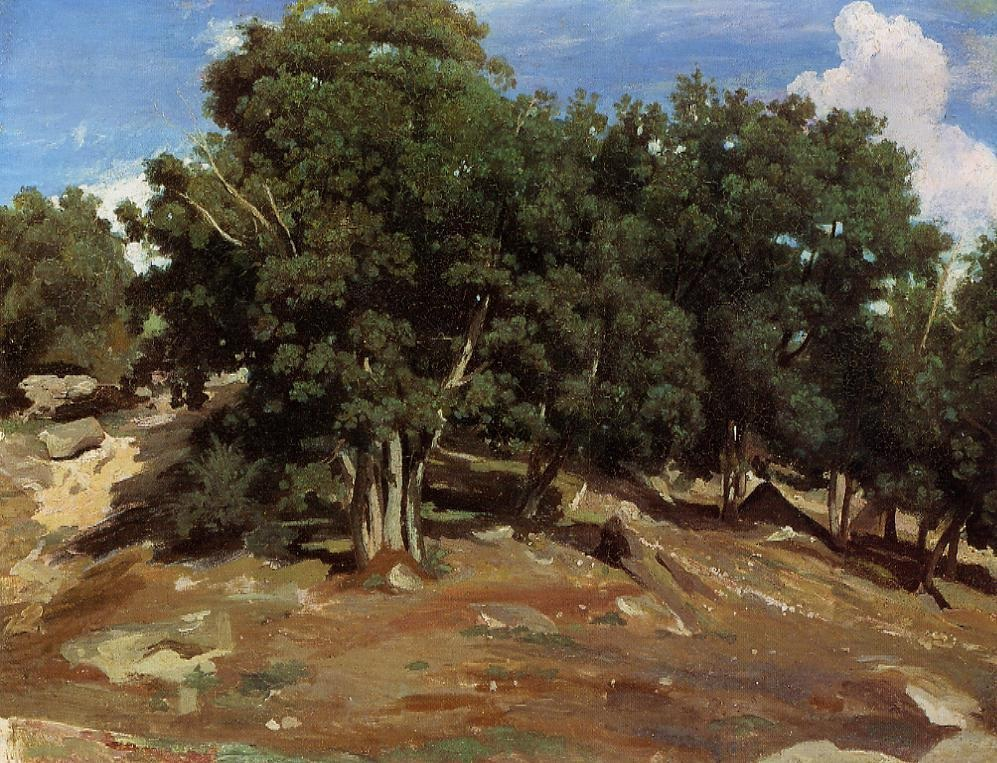What is this photo about? The image captures a tranquil landscape primarily consisting of a cluster of tall, lush green trees situated on a rocky hillside. These trees, standing proudly and full of life, extend their branches toward the open sky, their leaves weaving a beautiful green tapestry against the patches of blue sky visible above. The terrain of the hillside is rugged, dotted with rocks and patches of grass, contributing to the scene's raw, natural charm. The painting is created in an impressionist style, characterized by loose brushstrokes that effectively depict the dynamic interplay of colors and light. The artist's skillful application of this style evokes a profound sense of serenity and harmony within nature, inviting viewers to pause and appreciate the beauty of the natural world. 